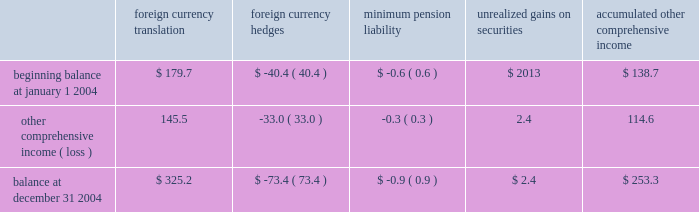Z i m m e r h o l d i n g s , i n c .
A n d s u b s i d i a r i e s 2 0 0 4 f o r m 1 0 - k notes to consolidated financial statements ( continued ) the components of accumulated other comprehensive income are as follows ( in millions ) : accumulated foreign foreign minimum unrealized other currency currency pension gains on comprehensive translation hedges liability securities income .
Accounting pronouncements 2013 in november 2004 , the no .
123 ( r ) requires all share-based payments to employees , fasb issued fasb staff position ( 2018 2018fsp 2019 2019 ) 109-1 , 2018 2018application including stock options , to be expensed based on their fair of fasb statement no .
109 , accounting for income taxes , to values .
The company has disclosed the effect on net earnings the tax deduction on qualified production activities and earnings per share if the company had applied the fair provided by the american jobs creation act of 2004 2019 2019 and value recognition provisions of sfas 123 .
Sfas 123 ( r ) fsp 109-2 , 2018 2018accounting and disclosure guidance for the contains three methodologies for adoption : 1 ) adopt foreign earnings repatriation provision within the american sfas 123 ( r ) on the effective date for interim periods jobs creation act of 2004 2019 2019 .
Fsp 109-1 states that a thereafter , 2 ) adopt sfas 123 ( r ) on the effective date for company 2019s deduction under the american jobs creation act interim periods thereafter and restate prior interim periods of 2004 ( the 2018 2018act 2019 2019 ) should be accounted for as a special included in the fiscal year of adoption under the provisions of deduction in accordance with sfas no .
109 and not as a tax sfas 123 , or 3 ) adopt sfas 123 ( r ) on the effective date for rate reduction .
Fsp 109-2 provides accounting and disclosure interim periods thereafter and restate all prior interim guidance for repatriation provisions included under the act .
Periods under the provisions of sfas 123 .
The company has fsp 109-1 and fsp 109-2 were both effective upon issuance .
Not determined an adoption methodology .
The company is in the adoption of these fsp 2019s did not have a material impact the process of assessing the impact that sfas 123 ( r ) will on the company 2019s financial position , results of operations or have on its financial position , results of operations and cash cash flows in 2004 .
Flows .
Sfas 123 ( r ) is effective for the company on july 1 , in november 2004 , the fasb issued sfas no .
151 , 2005 .
2018 2018inventory costs 2019 2019 to clarify the accounting for abnormal amounts of idle facility expense .
Sfas no .
151 requires that 3 .
Acquisitions fixed overhead production costs be applied to inventory at centerpulse ag and incentive capital ag 2018 2018normal capacity 2019 2019 and any excess fixed overhead production costs be charged to expense in the period in which they were on october 2 , 2003 ( the 2018 2018closing date 2019 2019 ) , the company incurred .
Sfas no .
151 is effective for fiscal years beginning closed its exchange offer for centerpulse , a global after june 15 , 2005 .
The company does not expect sfas orthopaedic medical device company headquartered in no .
151 to have a material impact on its financial position , switzerland that services the reconstructive joint , spine and results of operations , or cash flows .
Dental implant markets .
The company also closed its in december 2004 , the fasb issued sfas no .
153 , exchange offer for incentive , a company that , at the closing 2018 2018exchanges of nonmonetary assets 2019 2019 , which is effective for date , owned only cash and beneficially owned 18.3 percent of fiscal years beginning after june 15 , 2004 .
The company does the issued centerpulse shares .
The primary reason for not routinely engage in exchanges of nonmonetary assets ; as making the centerpulse and incentive exchange offers ( the such , sfas no .
153 is not expected to have a material impact 2018 2018exchange offers 2019 2019 ) was to create a global leader in the on the company 2019s financial position , results of operations or design , development , manufacture and marketing of cash flows .
Orthopaedic reconstructive implants , including joint and in may 2004 , the fasb issued fsp 106-2 2018 2018accounting dental , spine implants , and trauma products .
The strategic and disclosure requirements related to the medicare compatibility of the products and technologies of the prescription drug , improvement and modernization act of company and centerpulse is expected to provide significant 2003 2019 2019 , which is effective for the first interim or annual period earnings power and a strong platform from which it can beginning after june 15 , 2004 .
The company does not expect actively pursue growth opportunities in the industry .
For the to be eligible for the federal subsidy available pursuant to the company , centerpulse provides a unique platform for growth medicare prescription drug improvement and modernization and diversification in europe as well as in the spine and act of 2003 ; therefore , this staff position did not have a dental areas of the medical device industry .
As a result of the material impact on the company 2019s results of operations , exchange offers , the company beneficially owned financial position or cash flow .
98.7 percent of the issued centerpulse shares ( including the in december 2004 , the fasb issued sfas no .
123 ( r ) , centerpulse shares owned by incentive ) and 99.9 percent of 2018 2018share-based payment 2019 2019 , which is a revision to sfas no .
123 , the issued incentive shares on the closing date .
2018 2018accounting for stock based compensation 2019 2019 .
Sfas .
What was the percentage change in foreign currency translation in 2004? 
Computations: (145.5 / 179.7)
Answer: 0.80968. 